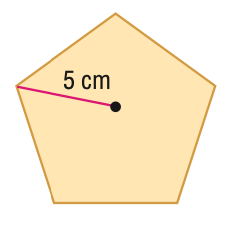Answer the mathemtical geometry problem and directly provide the correct option letter.
Question: Find the area of the regular polygon. Round to the nearest tenth.
Choices: A: 11.9 B: 29.7 C: 59.4 D: 118.9 C 